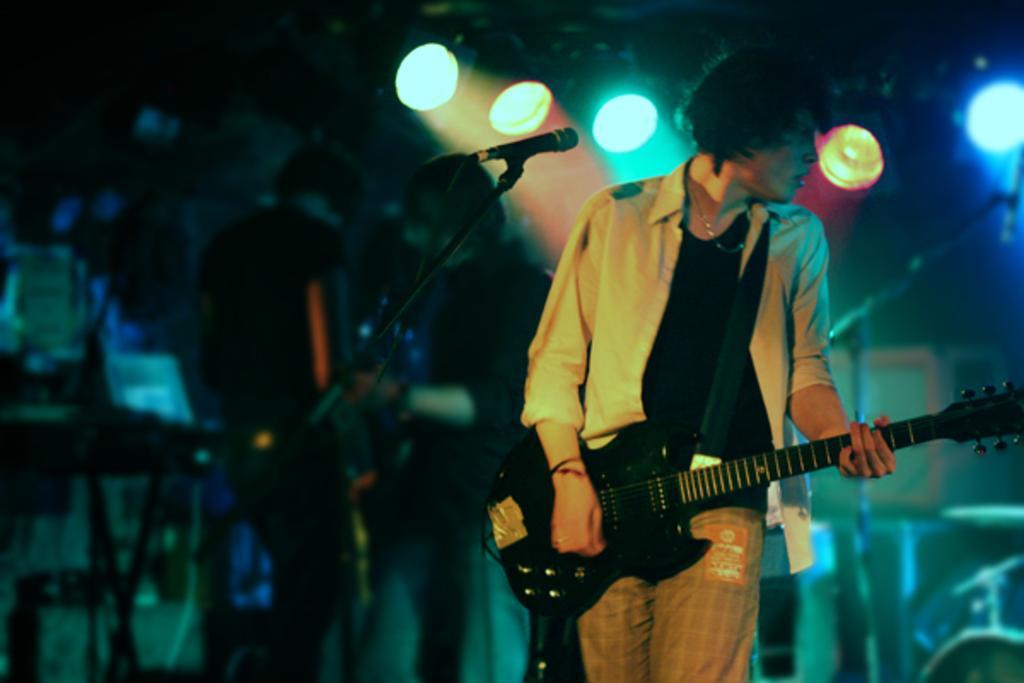How would you summarize this image in a sentence or two? A man is Standing in the right and hand holding a guitar. He wear a good dress behind him there are disco lights and in the left few people are standing. 